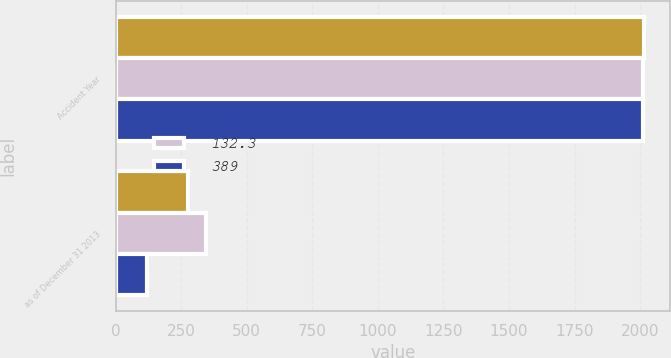Convert chart to OTSL. <chart><loc_0><loc_0><loc_500><loc_500><stacked_bar_chart><ecel><fcel>Accident Year<fcel>as of December 31 2013<nl><fcel>nan<fcel>2013<fcel>276<nl><fcel>132.3<fcel>2011<fcel>346<nl><fcel>389<fcel>2011<fcel>117.9<nl></chart> 